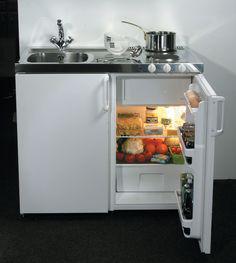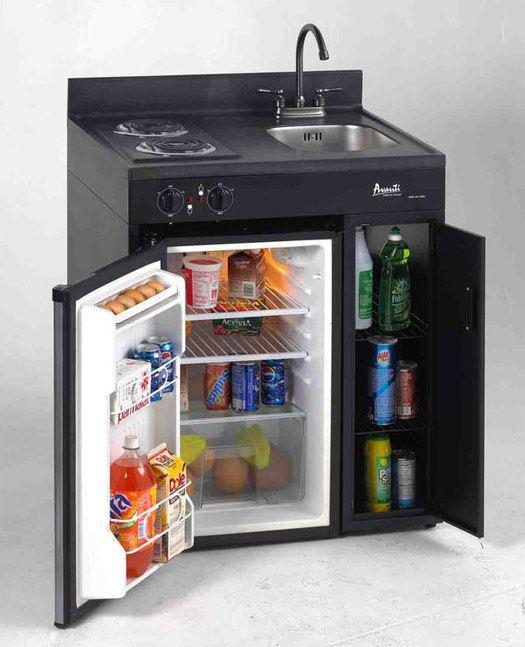The first image is the image on the left, the second image is the image on the right. For the images displayed, is the sentence "In at least one image there is a small fridge that door is open to the right." factually correct? Answer yes or no. Yes. 